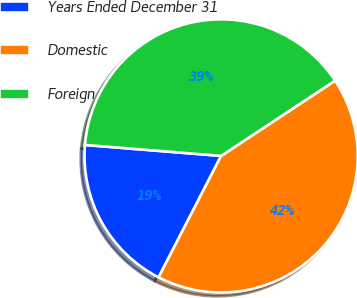Convert chart. <chart><loc_0><loc_0><loc_500><loc_500><pie_chart><fcel>Years Ended December 31<fcel>Domestic<fcel>Foreign<nl><fcel>18.71%<fcel>41.86%<fcel>39.43%<nl></chart> 